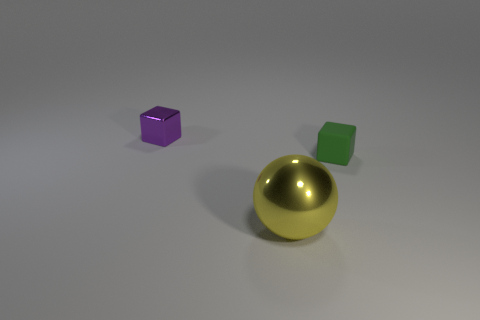Is there anything else that has the same material as the green block?
Keep it short and to the point. No. There is a object that is right of the yellow shiny thing that is right of the thing left of the big yellow object; what is it made of?
Give a very brief answer. Rubber. How many objects are blocks that are behind the small green thing or things that are right of the small purple shiny cube?
Make the answer very short. 3. There is a green object that is the same shape as the purple shiny thing; what material is it?
Ensure brevity in your answer.  Rubber. What number of matte things are either cyan blocks or big spheres?
Provide a succinct answer. 0. What shape is the thing that is the same material as the tiny purple cube?
Offer a very short reply. Sphere. How many other green rubber objects have the same shape as the small green thing?
Provide a succinct answer. 0. There is a metallic object that is behind the small matte object; is it the same shape as the small object to the right of the large sphere?
Keep it short and to the point. Yes. What number of things are green matte blocks or small blocks behind the green object?
Make the answer very short. 2. What number of metal things have the same size as the matte block?
Keep it short and to the point. 1. 